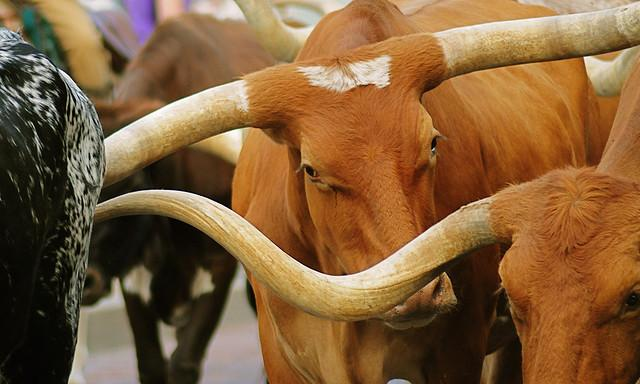What are long horn cows called? Please explain your reasoning. longhorn cattle. The cows are known for their long horns. 